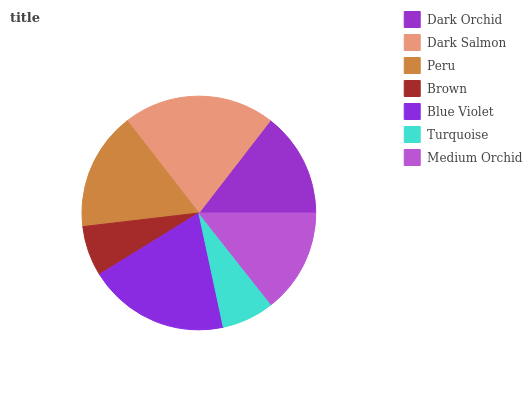Is Brown the minimum?
Answer yes or no. Yes. Is Dark Salmon the maximum?
Answer yes or no. Yes. Is Peru the minimum?
Answer yes or no. No. Is Peru the maximum?
Answer yes or no. No. Is Dark Salmon greater than Peru?
Answer yes or no. Yes. Is Peru less than Dark Salmon?
Answer yes or no. Yes. Is Peru greater than Dark Salmon?
Answer yes or no. No. Is Dark Salmon less than Peru?
Answer yes or no. No. Is Dark Orchid the high median?
Answer yes or no. Yes. Is Dark Orchid the low median?
Answer yes or no. Yes. Is Dark Salmon the high median?
Answer yes or no. No. Is Dark Salmon the low median?
Answer yes or no. No. 